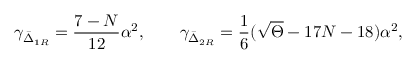Convert formula to latex. <formula><loc_0><loc_0><loc_500><loc_500>\gamma _ { \bar { \Delta } _ { 1 R } } = \frac { 7 - N } { 1 2 } \alpha ^ { 2 } , \quad \gamma _ { \bar { \Delta } _ { 2 R } } = \frac { 1 } { 6 } ( \sqrt { \Theta } - 1 7 N - 1 8 ) \alpha ^ { 2 } ,</formula> 